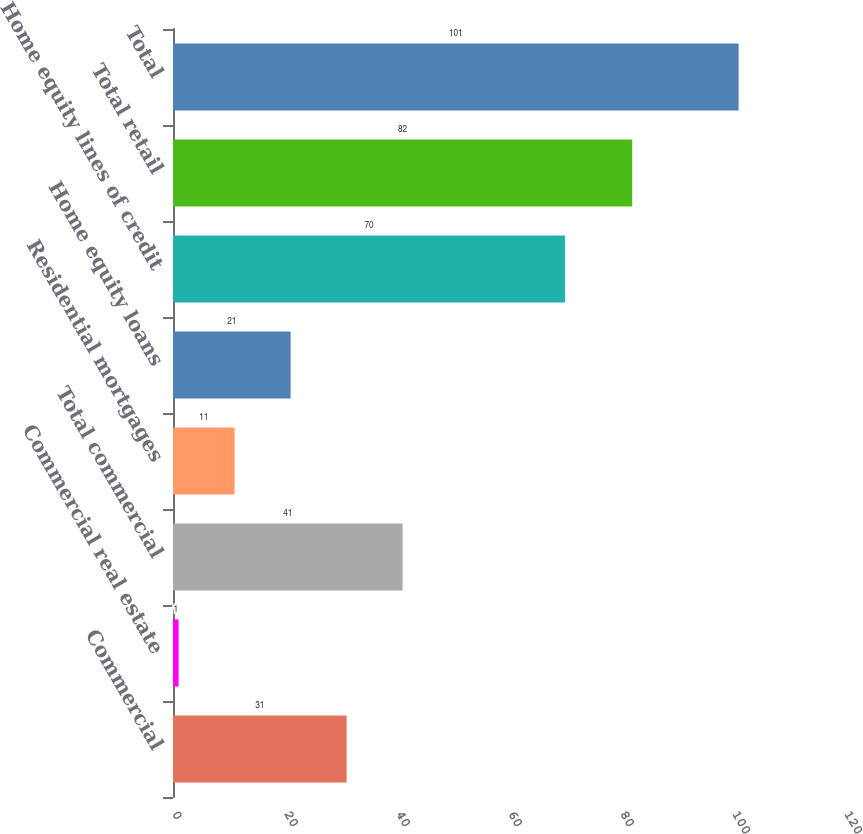Convert chart. <chart><loc_0><loc_0><loc_500><loc_500><bar_chart><fcel>Commercial<fcel>Commercial real estate<fcel>Total commercial<fcel>Residential mortgages<fcel>Home equity loans<fcel>Home equity lines of credit<fcel>Total retail<fcel>Total<nl><fcel>31<fcel>1<fcel>41<fcel>11<fcel>21<fcel>70<fcel>82<fcel>101<nl></chart> 